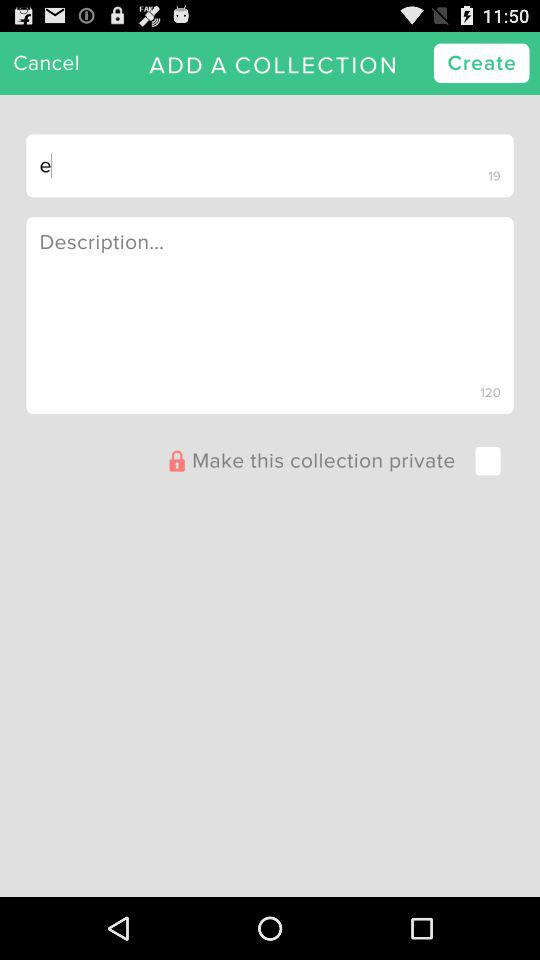How many text inputs are in the collection creation screen?
Answer the question using a single word or phrase. 2 